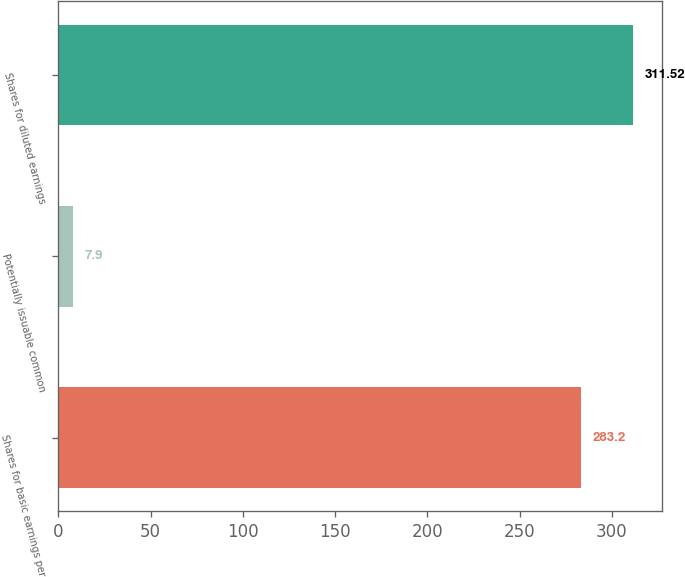Convert chart. <chart><loc_0><loc_0><loc_500><loc_500><bar_chart><fcel>Shares for basic earnings per<fcel>Potentially issuable common<fcel>Shares for diluted earnings<nl><fcel>283.2<fcel>7.9<fcel>311.52<nl></chart> 